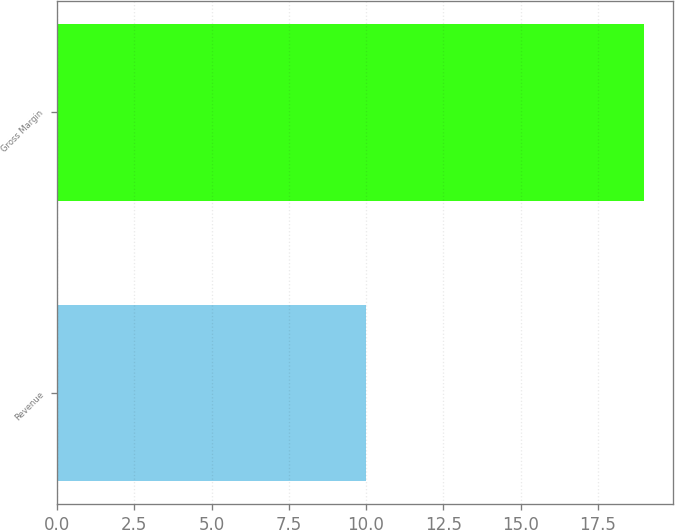Convert chart. <chart><loc_0><loc_0><loc_500><loc_500><bar_chart><fcel>Revenue<fcel>Gross Margin<nl><fcel>10<fcel>19<nl></chart> 